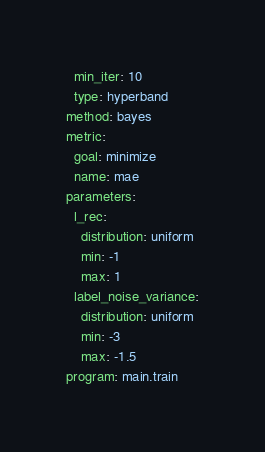<code> <loc_0><loc_0><loc_500><loc_500><_YAML_>  min_iter: 10
  type: hyperband
method: bayes
metric:
  goal: minimize
  name: mae
parameters:
  l_rec:
    distribution: uniform
    min: -1
    max: 1
  label_noise_variance:
    distribution: uniform
    min: -3
    max: -1.5
program: main.train
</code> 